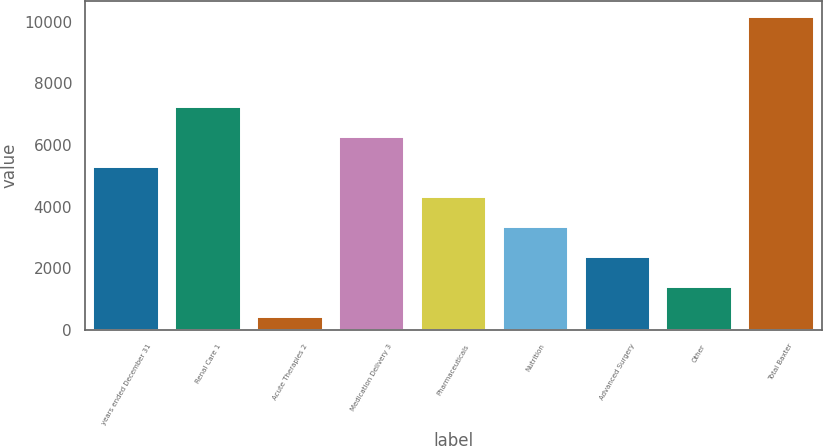Convert chart. <chart><loc_0><loc_0><loc_500><loc_500><bar_chart><fcel>years ended December 31<fcel>Renal Care 1<fcel>Acute Therapies 2<fcel>Medication Delivery 3<fcel>Pharmaceuticals<fcel>Nutrition<fcel>Advanced Surgery<fcel>Other<fcel>Total Baxter<nl><fcel>5296<fcel>7242.8<fcel>429<fcel>6269.4<fcel>4322.6<fcel>3349.2<fcel>2375.8<fcel>1402.4<fcel>10163<nl></chart> 